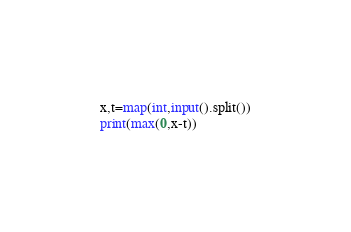<code> <loc_0><loc_0><loc_500><loc_500><_Python_>x,t=map(int,input().split())
print(max(0,x-t))</code> 